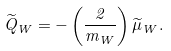<formula> <loc_0><loc_0><loc_500><loc_500>\widetilde { Q } _ { W } = - \left ( \frac { 2 } { m _ { W } } \right ) \widetilde { \mu } _ { W } .</formula> 